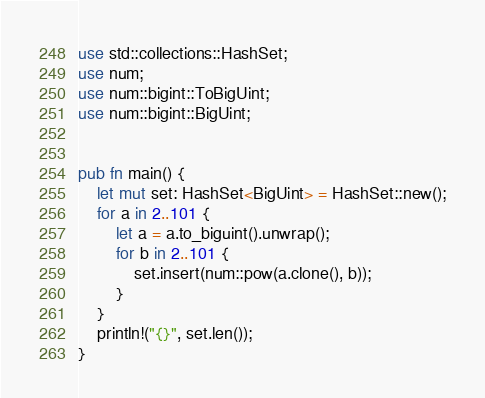Convert code to text. <code><loc_0><loc_0><loc_500><loc_500><_Rust_>use std::collections::HashSet;
use num;
use num::bigint::ToBigUint;
use num::bigint::BigUint;


pub fn main() {
    let mut set: HashSet<BigUint> = HashSet::new();
    for a in 2..101 {
        let a = a.to_biguint().unwrap();
        for b in 2..101 {
            set.insert(num::pow(a.clone(), b));
        }
    }
    println!("{}", set.len());
}
</code> 